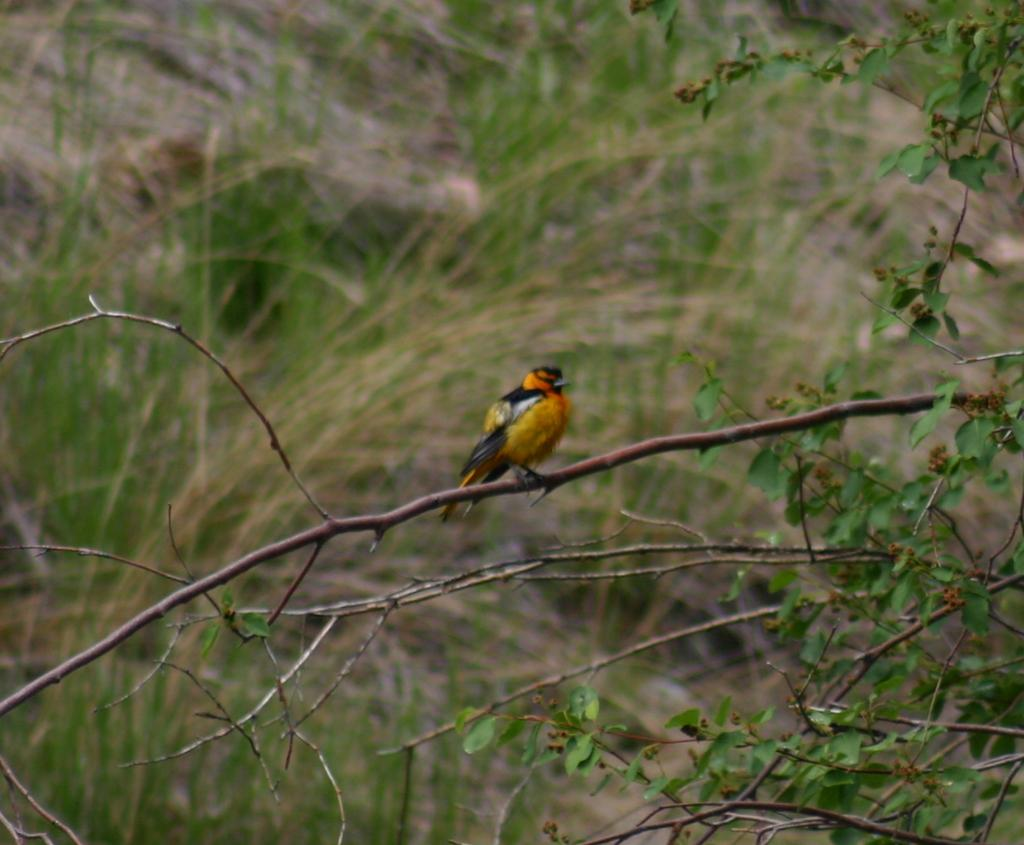What type of animal can be seen in the image? There is a bird in the image. Where is the bird located? The bird is standing on a branch. What can be seen in the background of the image? There is grass visible in the background of the image. How many eggs can be seen in the image? There are no eggs visible in the image. What type of sail is attached to the bird in the image? There is no sail present in the image, as it features a bird standing on a branch. 